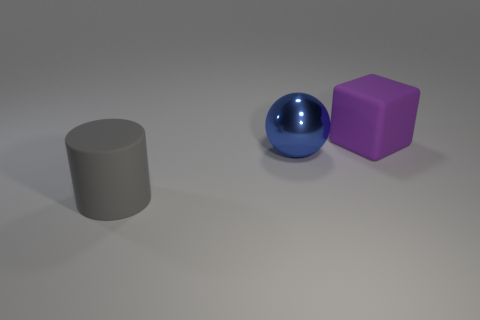Add 3 purple matte things. How many objects exist? 6 Subtract all gray spheres. How many cyan cylinders are left? 0 Subtract all brown cylinders. Subtract all large purple matte cubes. How many objects are left? 2 Add 3 blocks. How many blocks are left? 4 Add 1 large cylinders. How many large cylinders exist? 2 Subtract 0 purple cylinders. How many objects are left? 3 Subtract all spheres. How many objects are left? 2 Subtract 1 cubes. How many cubes are left? 0 Subtract all red cylinders. Subtract all purple balls. How many cylinders are left? 1 